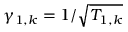<formula> <loc_0><loc_0><loc_500><loc_500>\gamma _ { 1 , k } = 1 / \sqrt { T _ { 1 , k } }</formula> 